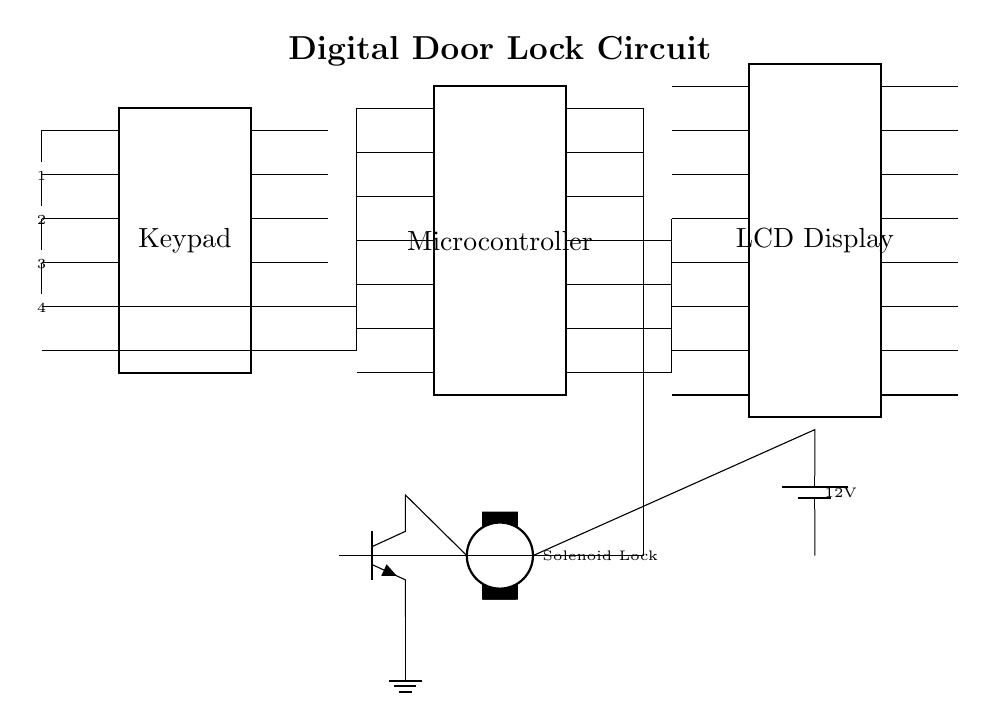What is the primary function of the microcontroller in this circuit? The microcontroller interprets inputs from the keypad and controls the solenoid lock based on the entered code.
Answer: Control of solenoid lock What voltage does the circuit operate on? The power supply indicates a voltage of 12 volts which is used to power the solenoid lock.
Answer: 12 volts How many pins does the keypad have? The keypad component in the diagram shows it has 12 pins for input/output functionality.
Answer: 12 pins What type of lock is used in this circuit? The circuit uses a solenoid lock, which is evident from the labeled component in the diagram.
Answer: Solenoid lock How does the microcontroller communicate with the LCD display? The microcontroller connects to the LCD display through four specific pins designated for data transmission, which are shown in the connections from the microcontroller to the LCD.
Answer: Four pins Which component controls the solenoid lock? A transistor is used in the circuit to control the solenoid lock when activated by the microcontroller’s signal.
Answer: Transistor What is the role of the keypad in this circuit? The keypad is used for user input, allowing entry of a security code to unlock the door.
Answer: User input 